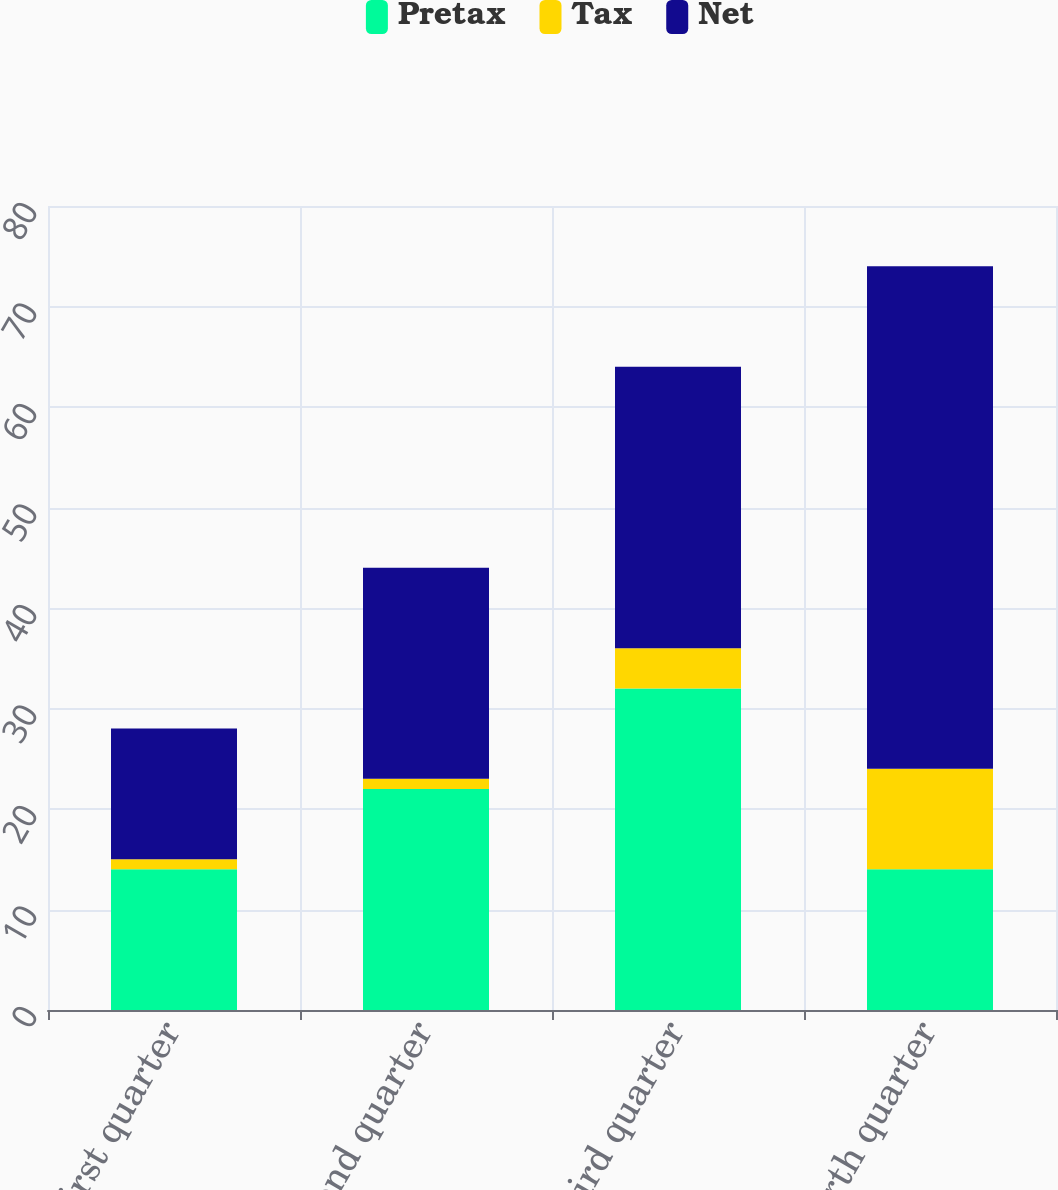Convert chart. <chart><loc_0><loc_0><loc_500><loc_500><stacked_bar_chart><ecel><fcel>First quarter<fcel>Second quarter<fcel>Third quarter<fcel>Fourth quarter<nl><fcel>Pretax<fcel>14<fcel>22<fcel>32<fcel>14<nl><fcel>Tax<fcel>1<fcel>1<fcel>4<fcel>10<nl><fcel>Net<fcel>13<fcel>21<fcel>28<fcel>50<nl></chart> 